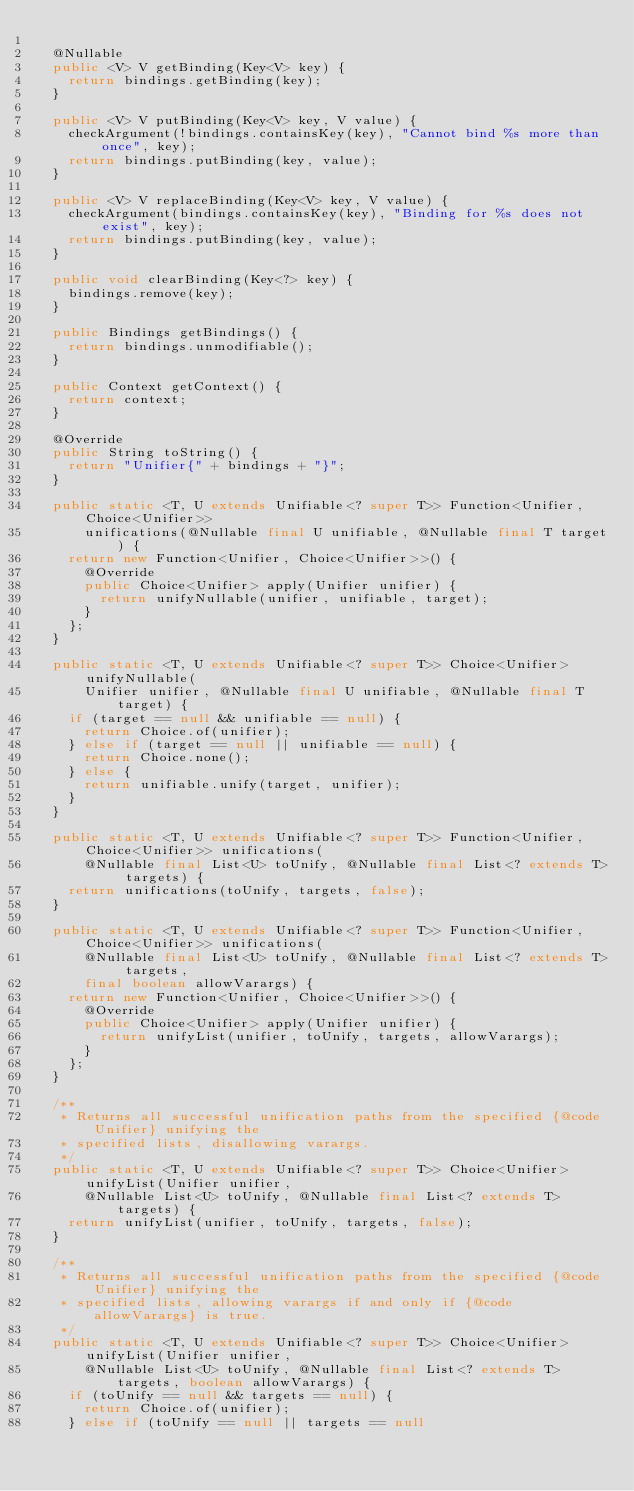<code> <loc_0><loc_0><loc_500><loc_500><_Java_>
  @Nullable
  public <V> V getBinding(Key<V> key) {
    return bindings.getBinding(key);
  }

  public <V> V putBinding(Key<V> key, V value) {
    checkArgument(!bindings.containsKey(key), "Cannot bind %s more than once", key);
    return bindings.putBinding(key, value);
  }

  public <V> V replaceBinding(Key<V> key, V value) {
    checkArgument(bindings.containsKey(key), "Binding for %s does not exist", key);
    return bindings.putBinding(key, value);
  }
  
  public void clearBinding(Key<?> key) {
    bindings.remove(key);
  }

  public Bindings getBindings() {
    return bindings.unmodifiable();
  }

  public Context getContext() {
    return context;
  }
  
  @Override
  public String toString() {
    return "Unifier{" + bindings + "}";
  }

  public static <T, U extends Unifiable<? super T>> Function<Unifier, Choice<Unifier>> 
      unifications(@Nullable final U unifiable, @Nullable final T target) {
    return new Function<Unifier, Choice<Unifier>>() {
      @Override
      public Choice<Unifier> apply(Unifier unifier) {
        return unifyNullable(unifier, unifiable, target);
      }
    };
  }
  
  public static <T, U extends Unifiable<? super T>> Choice<Unifier> unifyNullable(
      Unifier unifier, @Nullable final U unifiable, @Nullable final T target) {
    if (target == null && unifiable == null) {
      return Choice.of(unifier);
    } else if (target == null || unifiable == null) {
      return Choice.none();
    } else {
      return unifiable.unify(target, unifier);
    }
  }

  public static <T, U extends Unifiable<? super T>> Function<Unifier, Choice<Unifier>> unifications(
      @Nullable final List<U> toUnify, @Nullable final List<? extends T> targets) {
    return unifications(toUnify, targets, false);
  }

  public static <T, U extends Unifiable<? super T>> Function<Unifier, Choice<Unifier>> unifications(
      @Nullable final List<U> toUnify, @Nullable final List<? extends T> targets,
      final boolean allowVarargs) {
    return new Function<Unifier, Choice<Unifier>>() {
      @Override
      public Choice<Unifier> apply(Unifier unifier) {
        return unifyList(unifier, toUnify, targets, allowVarargs);
      }
    };
  }

  /**
   * Returns all successful unification paths from the specified {@code Unifier} unifying the
   * specified lists, disallowing varargs.
   */
  public static <T, U extends Unifiable<? super T>> Choice<Unifier> unifyList(Unifier unifier,
      @Nullable List<U> toUnify, @Nullable final List<? extends T> targets) {
    return unifyList(unifier, toUnify, targets, false);
  }

  /**
   * Returns all successful unification paths from the specified {@code Unifier} unifying the
   * specified lists, allowing varargs if and only if {@code allowVarargs} is true.
   */
  public static <T, U extends Unifiable<? super T>> Choice<Unifier> unifyList(Unifier unifier,
      @Nullable List<U> toUnify, @Nullable final List<? extends T> targets, boolean allowVarargs) {
    if (toUnify == null && targets == null) {
      return Choice.of(unifier);
    } else if (toUnify == null || targets == null</code> 